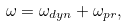<formula> <loc_0><loc_0><loc_500><loc_500>\omega = \omega _ { d y n } + \omega _ { p r } ,</formula> 